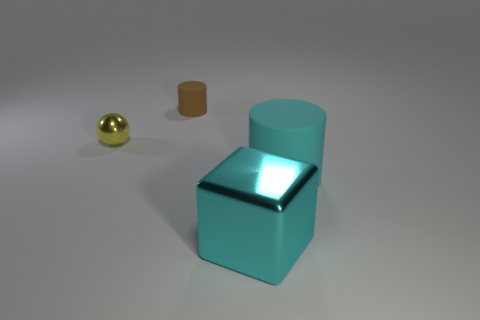Add 4 big green things. How many objects exist? 8 Subtract all brown cylinders. How many cylinders are left? 1 Subtract 0 red spheres. How many objects are left? 4 Subtract all balls. How many objects are left? 3 Subtract 1 balls. How many balls are left? 0 Subtract all blue cubes. Subtract all yellow cylinders. How many cubes are left? 1 Subtract all gray blocks. How many cyan cylinders are left? 1 Subtract all big cyan matte cylinders. Subtract all gray spheres. How many objects are left? 3 Add 4 large things. How many large things are left? 6 Add 1 cyan spheres. How many cyan spheres exist? 1 